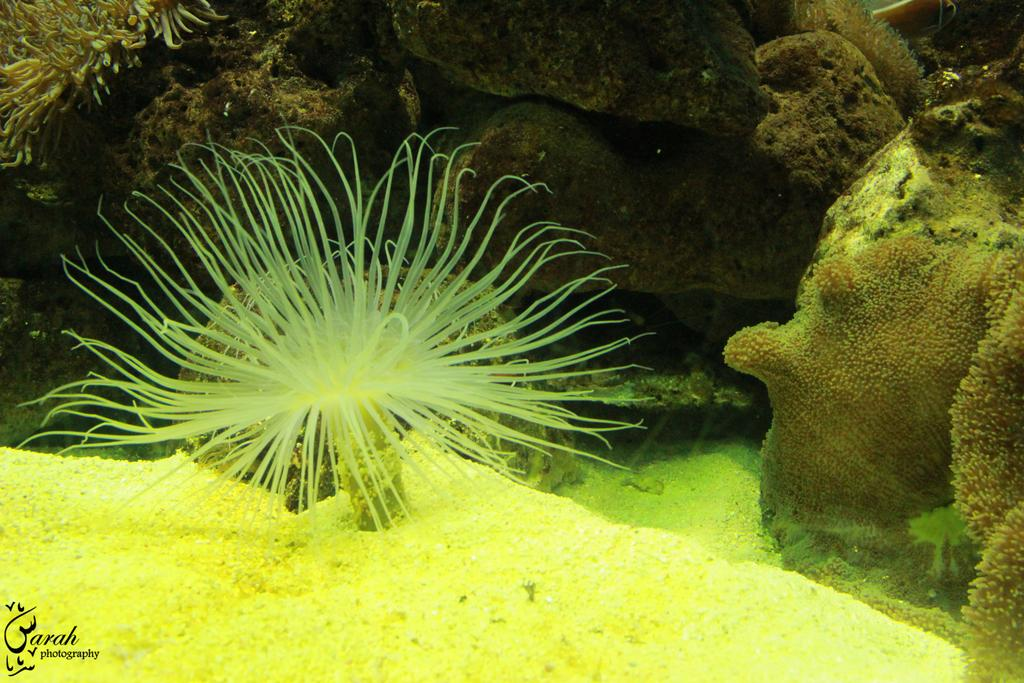What type of plants are visible in the foreground of the image? There are sea plants in the foreground of the image. What else can be seen under the water in the image? There are stones under the water in the image. What is the surface on which the sea plants and stones are located? The sea plants and stones are on the sand. What type of shoes are the sea plants wearing in the image? There are no shoes present in the image, as sea plants do not wear shoes. 